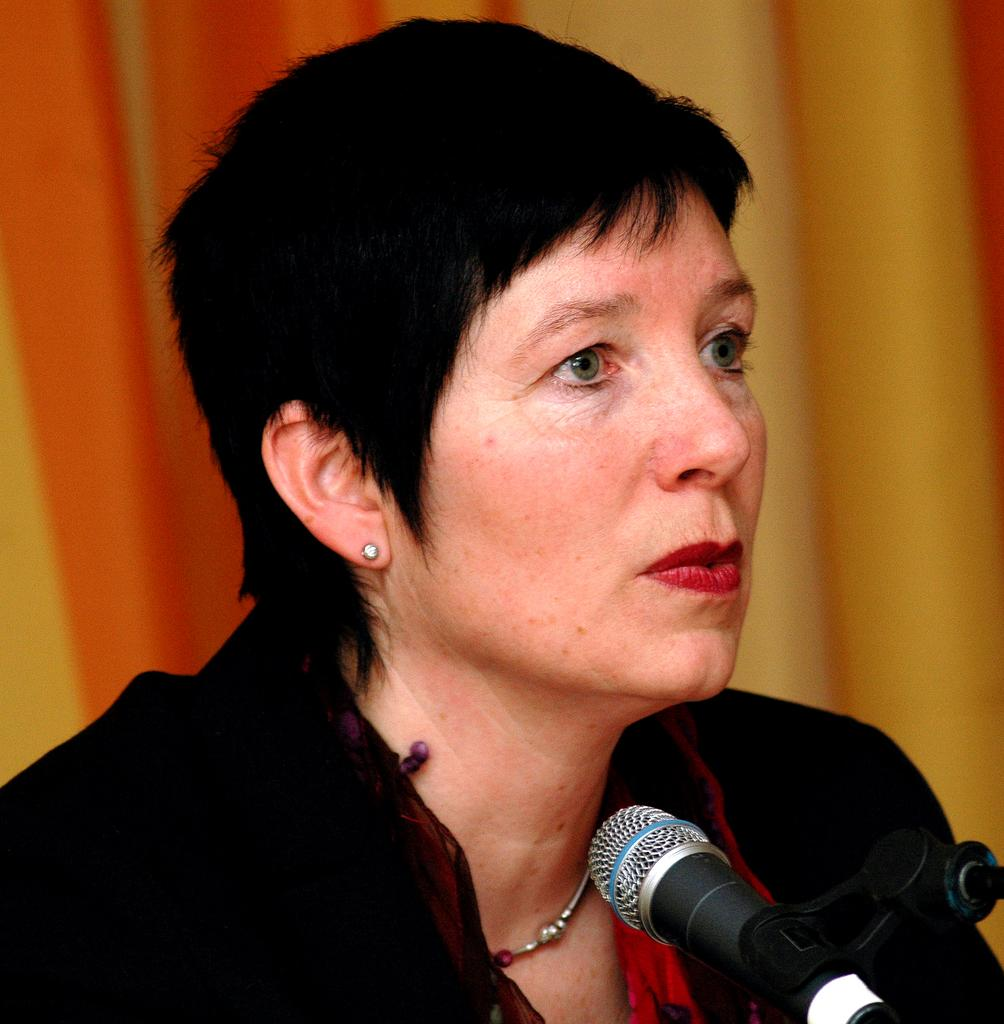Who is the main subject in the image? There is a lady in the image. What object is in front of the lady? There is a mic in front of the lady. Can you describe the background of the image? The background of the image is blurred. What type of design does the snail have in the image? There is no snail present in the image, so it is not possible to determine its design. 